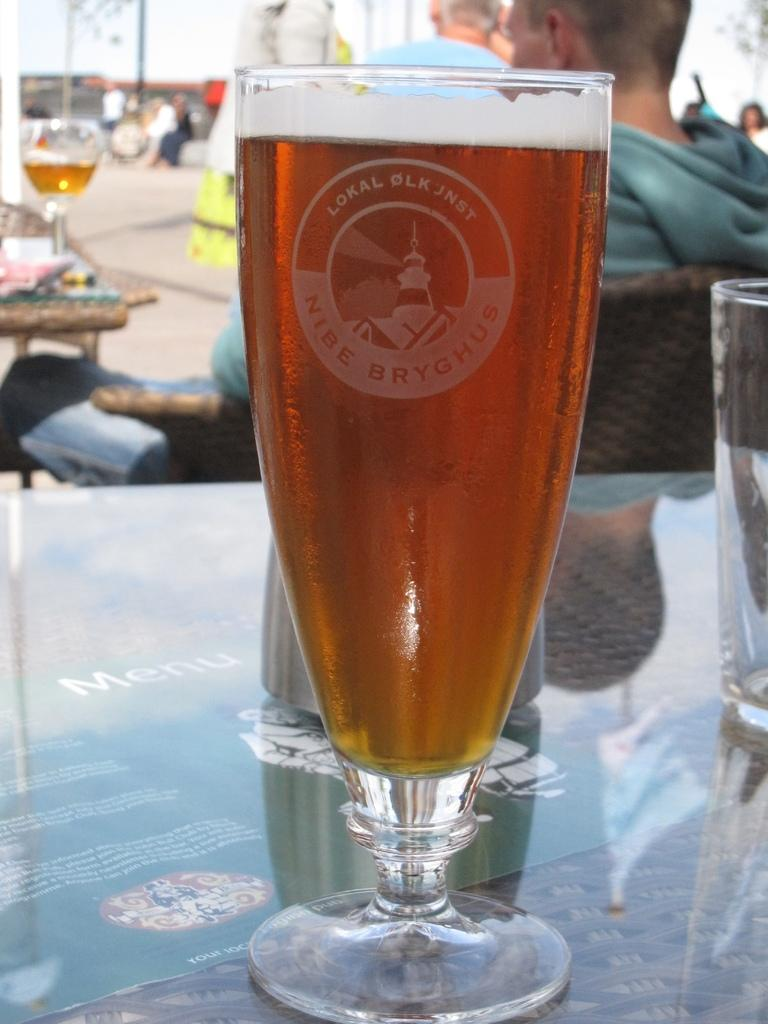<image>
Present a compact description of the photo's key features. Full glass of beer with Lokal Olk Jnst Nibe Bryghus etched on the front. 